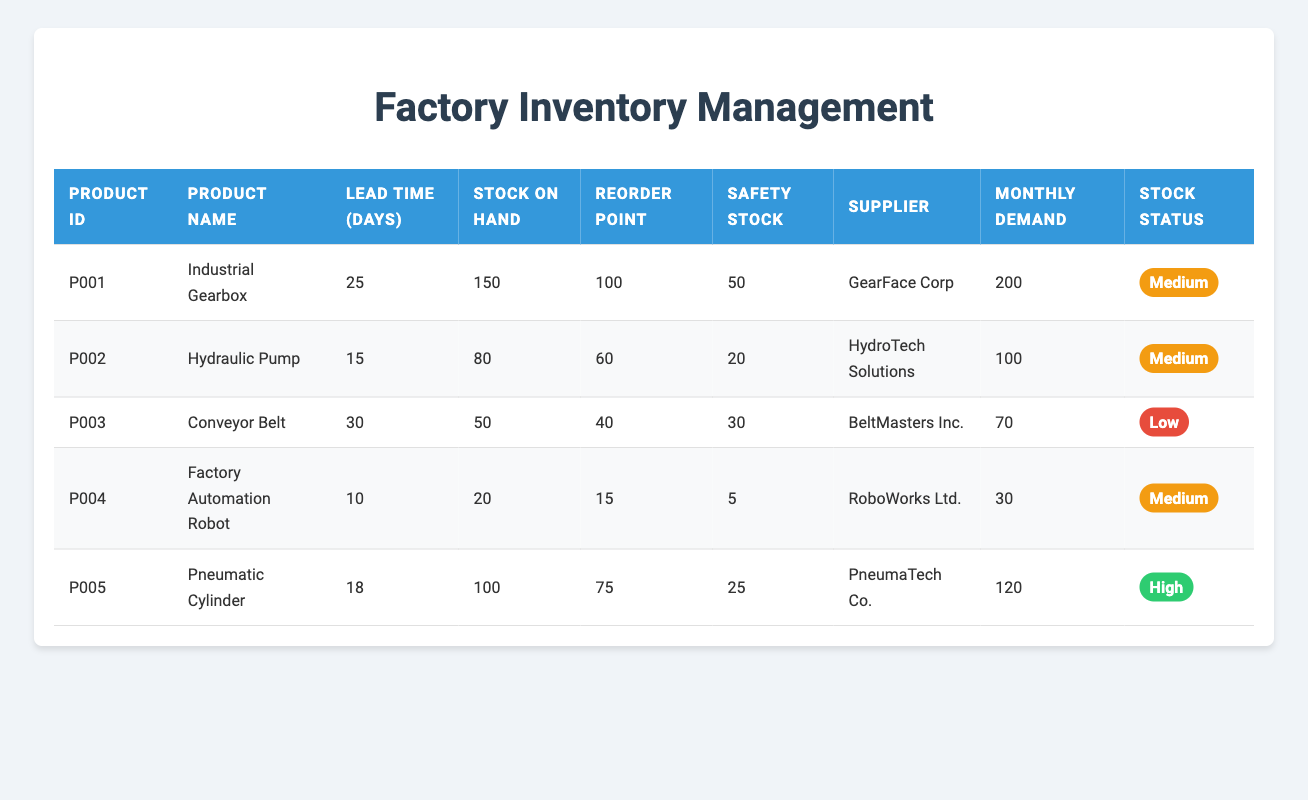What is the stock on hand for the Hydraulic Pump? Referring to the table under the "Stock on Hand" column for the Hydraulic Pump, the value listed is 80.
Answer: 80 Which product has the longest lead time? The lead times for each product are 25, 15, 30, 10, and 18 days respectively. Comparing these values, the longest lead time is 30 days for the Conveyor Belt.
Answer: 30 days Is the current stock for the Factory Automation Robot above its safety stock? The stock on hand for the Factory Automation Robot is 20, while its safety stock is 5. Since 20 is greater than 5, the statement is true.
Answer: Yes What is the average lead time of all products? The lead times are 25, 15, 30, 10, and 18 days. Summing these values gives 25 + 15 + 30 + 10 + 18 = 108 days. There are 5 products, so the average is 108 / 5 = 21.6 days.
Answer: 21.6 days How much safety stock does the Pneumatic Cylinder have compared to its monthly demand? The Pneumatic Cylinder has a safety stock of 25 and a monthly demand of 120. The safety stock is less than the monthly demand, indicating that it serves more as a buffer than full coverage.
Answer: 25 (less than monthly demand) What is the total stock on hand for products that have a lead time of less than 20 days? The products with a lead time of less than 20 days are the Factory Automation Robot (20 stock) and the Hydraulic Pump (80 stock). Adding these gives 20 + 80 = 100.
Answer: 100 Do any products have a stock status labeled as "High"? Checking the status column for each product, the Pneumatic Cylinder is the only product with a status labeled as "High." Therefore, the answer is true.
Answer: Yes Which product has a reorder point that is less than half of its monthly demand? The monthly demands are 200, 100, 70, 30, and 120 respectively. The reorder points are 100, 60, 40, 15, and 75. By checking, the reorder point of the Factory Automation Robot is 15, which is less than half of its monthly demand of 30 (half is 15).
Answer: Factory Automation Robot What is the difference between stock on hand and safety stock for the Conveyor Belt? For the Conveyor Belt, the stock on hand is 50 and the safety stock is 30. The difference is calculated by subtracting safety stock from stock on hand: 50 - 30 = 20.
Answer: 20 